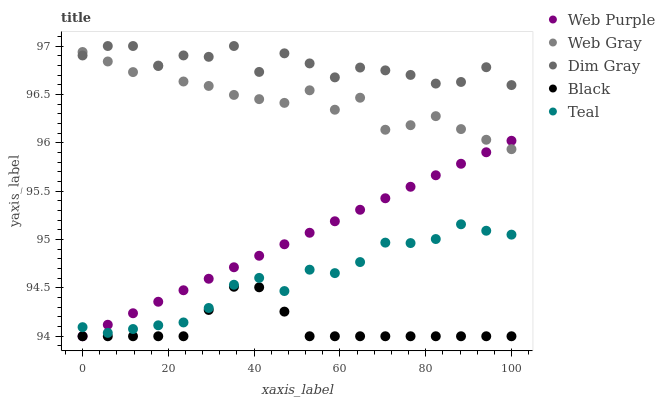Does Black have the minimum area under the curve?
Answer yes or no. Yes. Does Dim Gray have the maximum area under the curve?
Answer yes or no. Yes. Does Web Gray have the minimum area under the curve?
Answer yes or no. No. Does Web Gray have the maximum area under the curve?
Answer yes or no. No. Is Web Purple the smoothest?
Answer yes or no. Yes. Is Dim Gray the roughest?
Answer yes or no. Yes. Is Web Gray the smoothest?
Answer yes or no. No. Is Web Gray the roughest?
Answer yes or no. No. Does Web Purple have the lowest value?
Answer yes or no. Yes. Does Web Gray have the lowest value?
Answer yes or no. No. Does Dim Gray have the highest value?
Answer yes or no. Yes. Does Web Gray have the highest value?
Answer yes or no. No. Is Teal less than Web Gray?
Answer yes or no. Yes. Is Web Gray greater than Black?
Answer yes or no. Yes. Does Web Purple intersect Teal?
Answer yes or no. Yes. Is Web Purple less than Teal?
Answer yes or no. No. Is Web Purple greater than Teal?
Answer yes or no. No. Does Teal intersect Web Gray?
Answer yes or no. No. 